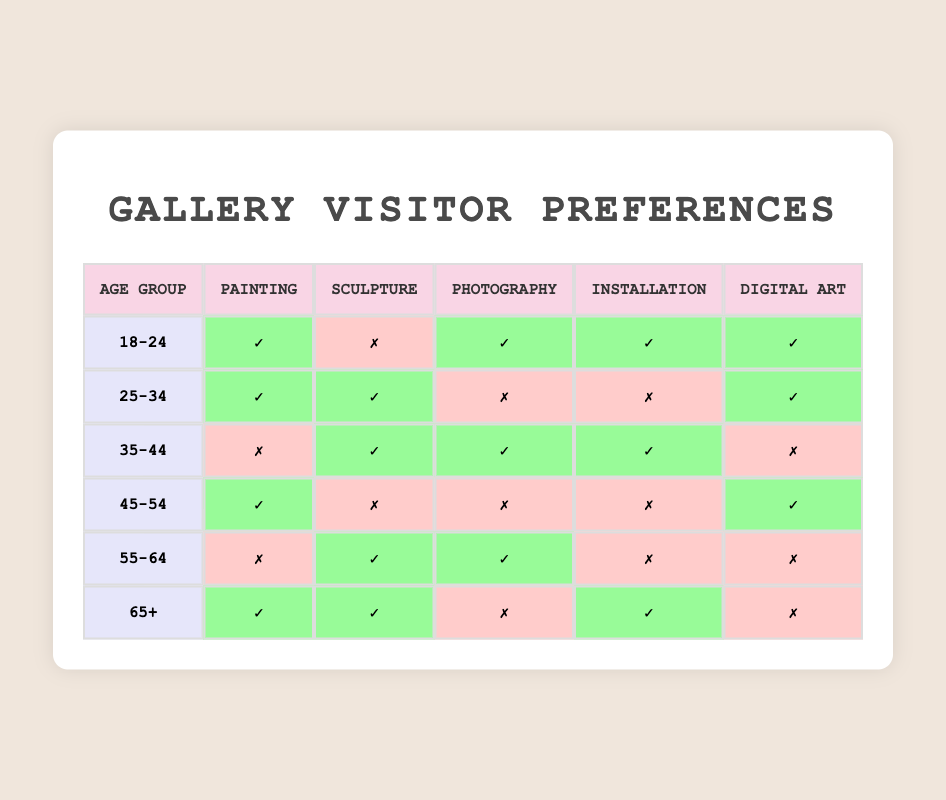What is the preference for painting among the 18-24 age group? The table shows that for the age group 18-24, the preference for painting is marked with a "✓," indicating that they do indeed have a preference for painting.
Answer: Yes Which age group has a preference for sculpture but not for photography? Looking through the table, the age group 35-44 shows a "✓" for sculpture and a "✗" for photography, fulfilling the criteria of having a preference for sculpture but not for photography.
Answer: 35-44 How many age groups have a preference for both digital art and installation? We can find the records in the table where both digital art and installation are marked with "✓". The age groups 18-24 and 65+ show this pattern. So, there are 2 age groups with this preference.
Answer: 2 Is there any age group with no preference for installation? By scanning through the table, the age groups 25-34, 35-44, and 55-64 show a "✗" under installation, confirming that these groups do not have a preference for installation. Thus, the answer is yes.
Answer: Yes Which age group has the highest overall diversity in artistic preferences? To determine this, we assess each age group's artistic preferences. The age group 25-34 shows 4 "✓" preferences (painting, sculpture, and digital art), whereas age group 35-44 also has 4 "✓" preferences (sculpture, photography, and installation). However, the 25-34 group is the only one with diversity across three different art forms combined with two "✗," making them the most varied.
Answer: 25-34 What is the preference for photography among the 45-54 age group? The table shows a "✗" next to photography for the 45-54 age group, which means they do not have a preference for photography.
Answer: No Which age group likes both painting and photography? The age groups that show a "✓" for both painting and photography are 18-24 and 35-44 according to the table. Hence, there are two age groups fitting this criterion.
Answer: 2 How many art forms does the 55-64 age group prefer? By reviewing the table, the 55-64 age group has preferences for sculpture and photography, indicated by "✓" in those columns but "✗" in the others. Thus, they prefer 2 art forms.
Answer: 2 